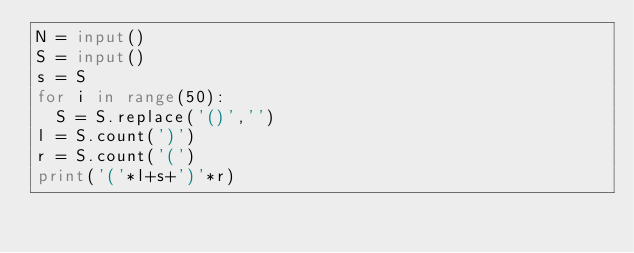Convert code to text. <code><loc_0><loc_0><loc_500><loc_500><_Python_>N = input()
S = input()
s = S
for i in range(50):
  S = S.replace('()','')
l = S.count(')')
r = S.count('(')
print('('*l+s+')'*r)</code> 